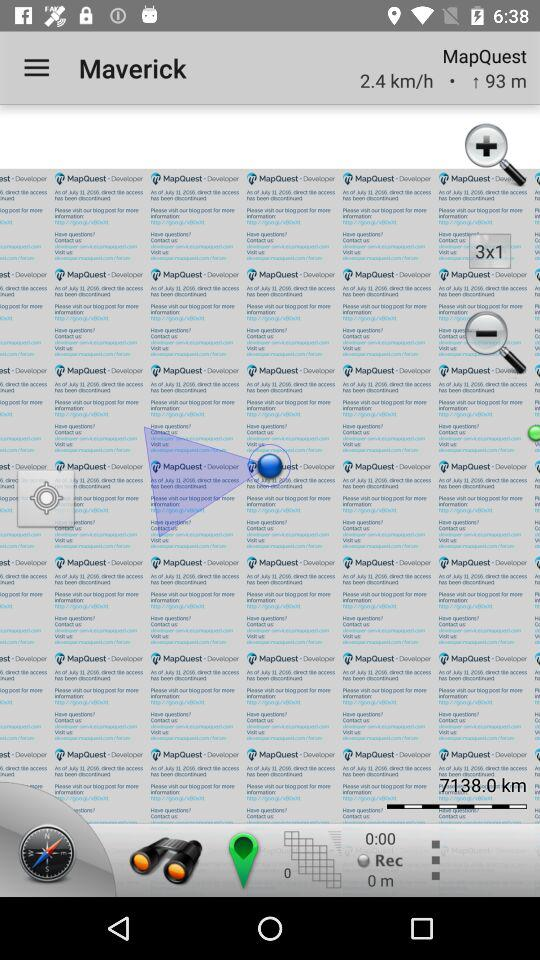How many meters is the user above sea level?
Answer the question using a single word or phrase. 93 m 